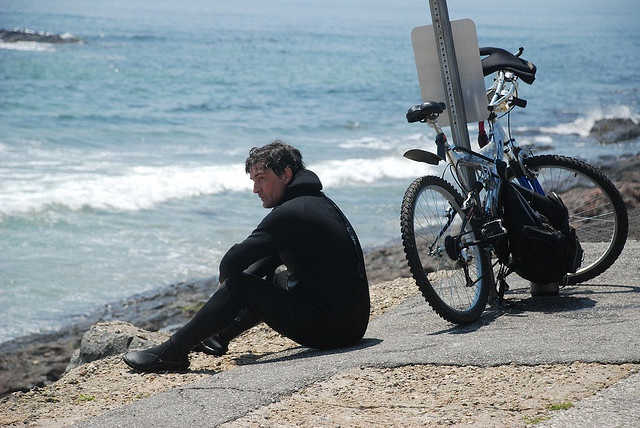Describe the objects in this image and their specific colors. I can see bicycle in darkgray, black, and gray tones, people in darkgray, black, gray, and maroon tones, and backpack in darkgray, black, and gray tones in this image. 